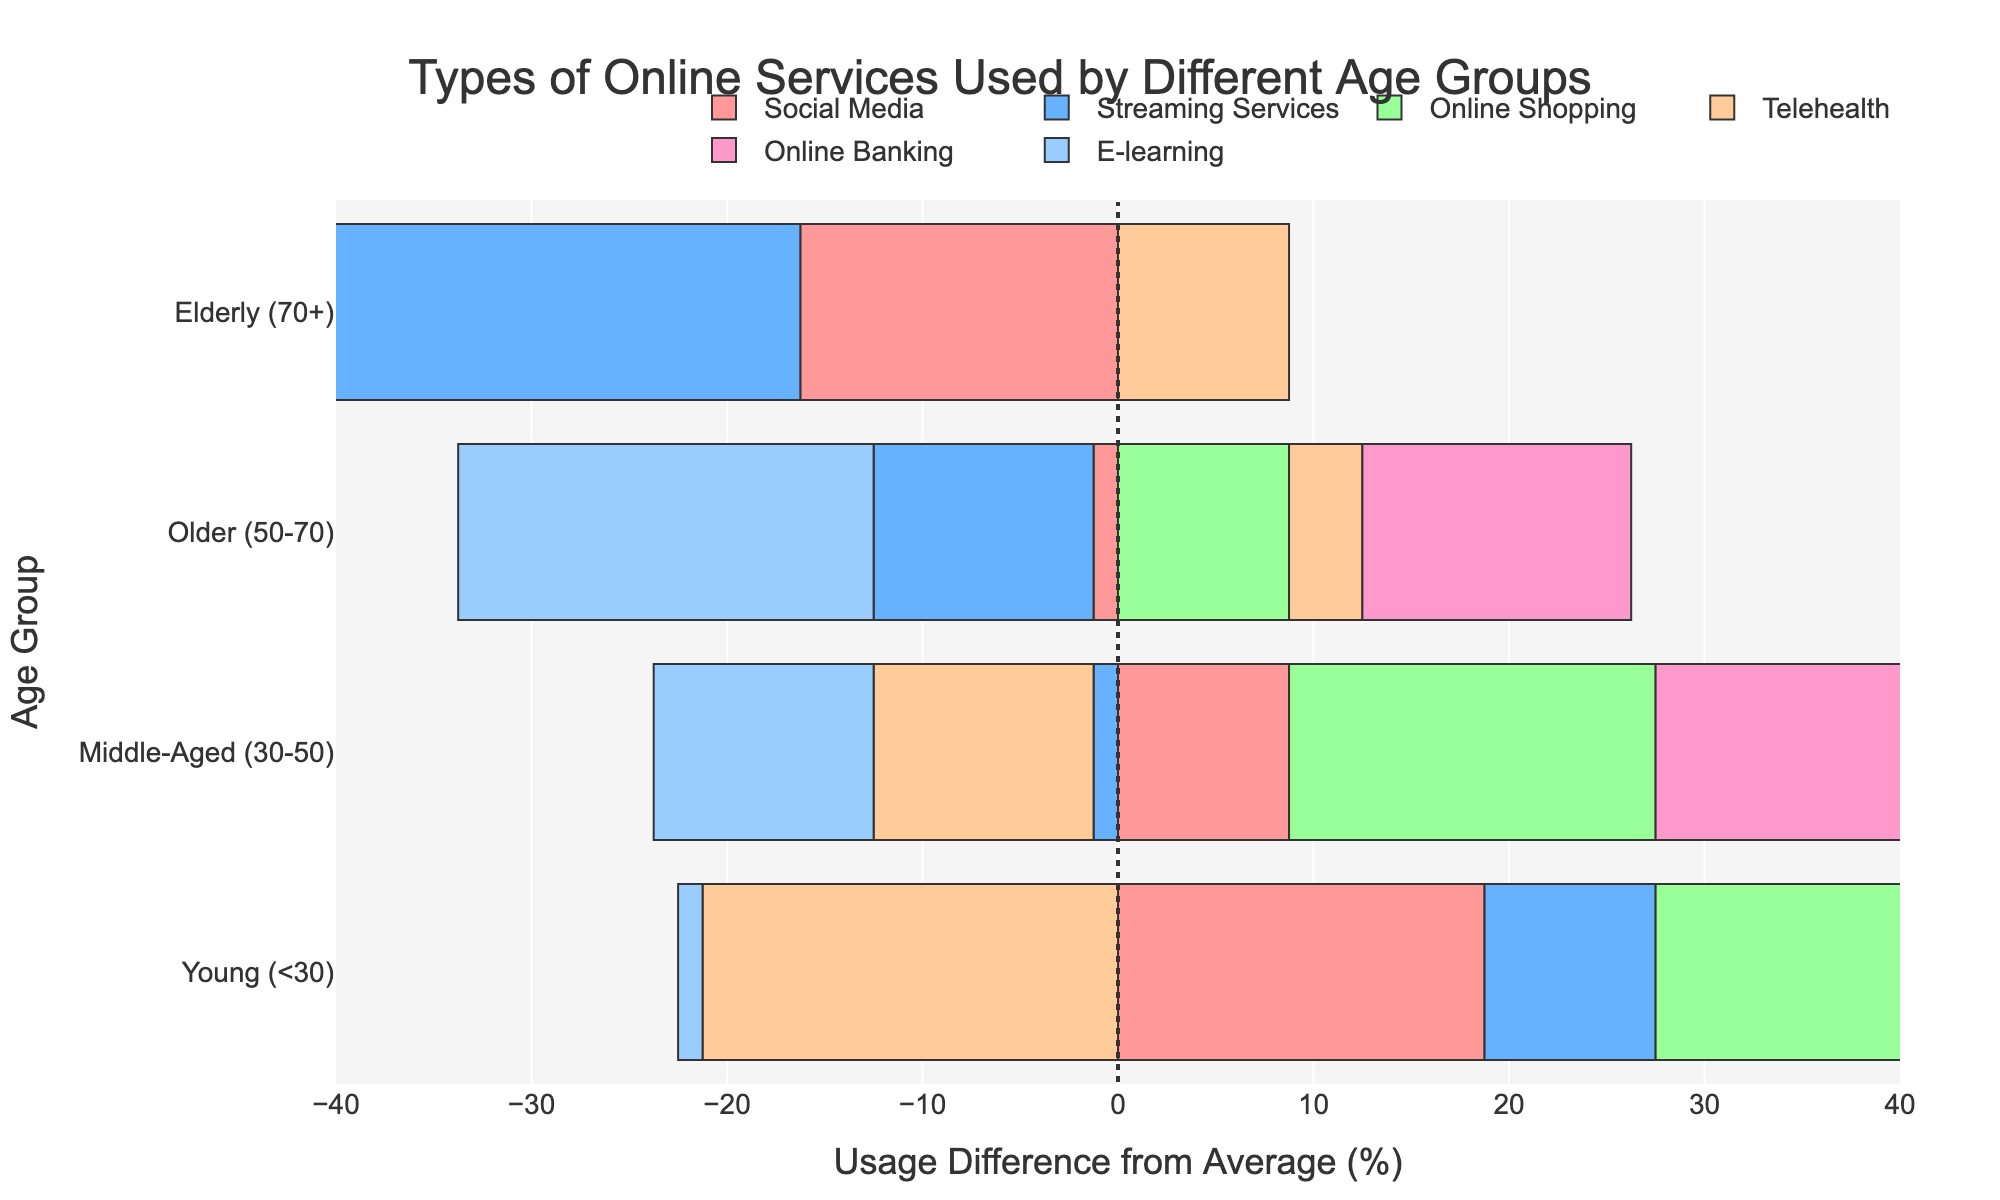what is the overall trend in the use of telehealth services among different age groups? From the plot, we see that the bar for Telehealth services for the Elderly (70+) is positive, indicating that it is above the average. For the Young (<30) and Middle-Aged (30-50) age groups, the bar is negative, indicating they use it less than the average. The Older (50-70) age group's bar is also positive, but to a smaller extent. This indicates a trend where telehealth services are used more by older age groups and less by younger ones.
Answer: More usage by older age groups which age group uses online shopping services the most? By looking at the bar that represents Online Shopping across different age groups, we find that the Young (<30) age group has the longest positive bar, suggesting they use online shopping services the most.
Answer: Young (<30) is the use of social media greater in the young age group compared to the elderly age group? The bar for Social Media among the Young (<30) is positive and extends far to the right, whereas the bar for Social Media among the Elderly (70+) is shorter and extends less far. This indicates that the use of social media is greater in the young age group compared to the elderly age group.
Answer: Yes what is the difference in the usage of e-learning services between the young and elderly age groups? The bar for E-learning for the Young (<30) extends positively to the right while the bar for the Elderly (70+) extends much less. The distance between the bars, visually, shows that the Young use these services much more compared to the Elderly. Subtract the Elderly bar length from the Young bar length for the exact difference in usage.
Answer: Substantially more in young do middle-aged individuals use online banking more or less than the average? The bar for Online Banking for the Middle-Aged (30-50) is slightly positive, indicating that this group's usage is just above the average.
Answer: Slightly more 